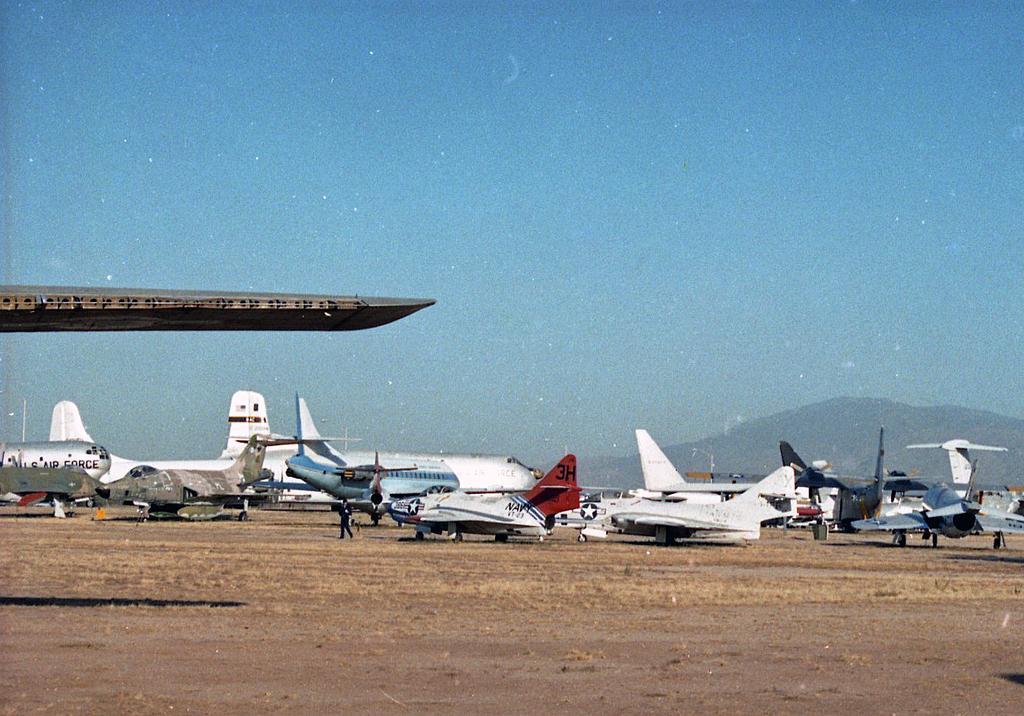Please provide a concise description of this image. In this picture there are aeroplanes at the bottom side of the image and there is sky at the top side of the image. 